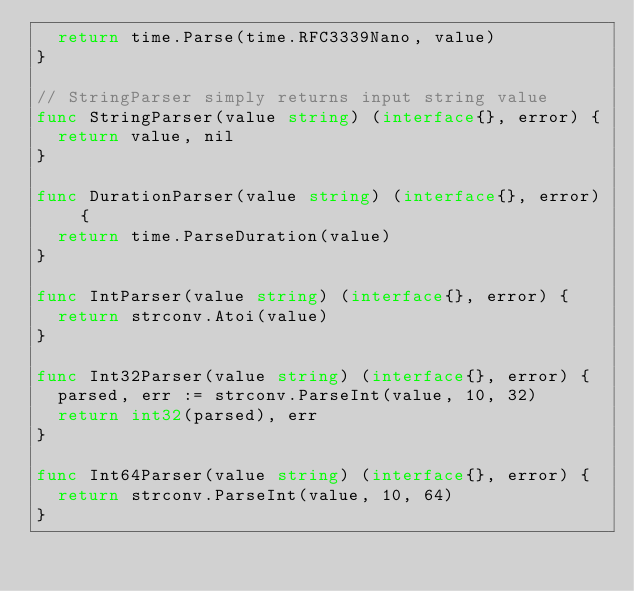<code> <loc_0><loc_0><loc_500><loc_500><_Go_>	return time.Parse(time.RFC3339Nano, value)
}

// StringParser simply returns input string value
func StringParser(value string) (interface{}, error) {
	return value, nil
}

func DurationParser(value string) (interface{}, error) {
	return time.ParseDuration(value)
}

func IntParser(value string) (interface{}, error) {
	return strconv.Atoi(value)
}

func Int32Parser(value string) (interface{}, error) {
	parsed, err := strconv.ParseInt(value, 10, 32)
	return int32(parsed), err
}

func Int64Parser(value string) (interface{}, error) {
	return strconv.ParseInt(value, 10, 64)
}
</code> 